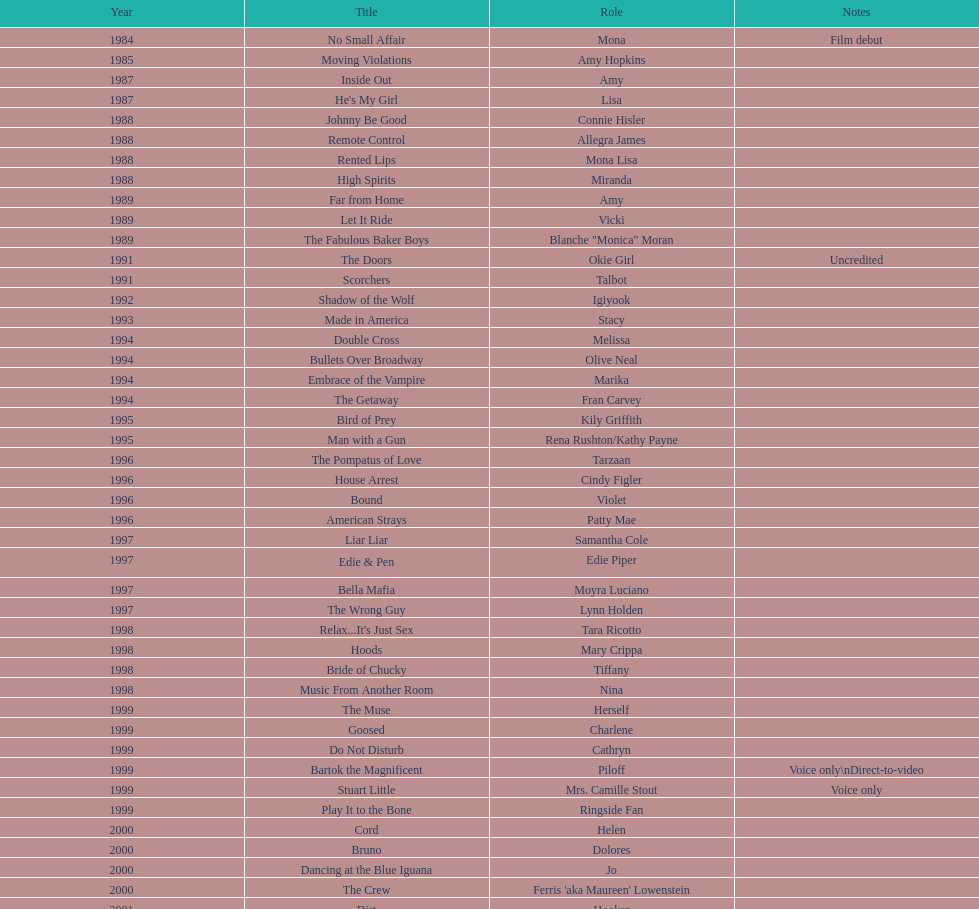How many films does jennifer tilly do a voice over role in? 5. 